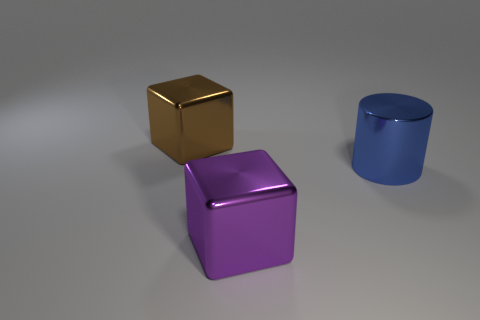There is a big object that is to the right of the brown block and behind the large purple metallic cube; what material is it?
Make the answer very short. Metal. Are there more large purple blocks that are on the right side of the big purple block than blue cylinders that are to the left of the big shiny cylinder?
Make the answer very short. No. Are there any other objects that have the same size as the brown metal object?
Ensure brevity in your answer.  Yes. There is a thing that is to the left of the purple block in front of the big metal thing right of the large purple metallic object; what is its size?
Keep it short and to the point. Large. The big metal cylinder is what color?
Offer a very short reply. Blue. Is the number of shiny cylinders that are to the left of the large brown shiny cube greater than the number of tiny purple objects?
Keep it short and to the point. No. There is a metallic cylinder; what number of large objects are in front of it?
Give a very brief answer. 1. Are there any large blue cylinders that are to the left of the large block that is right of the big metal object behind the large blue cylinder?
Offer a very short reply. No. Do the purple object and the brown metal block have the same size?
Your answer should be compact. Yes. Are there an equal number of large purple cubes in front of the big purple thing and purple objects behind the large blue metallic object?
Provide a short and direct response. Yes. 